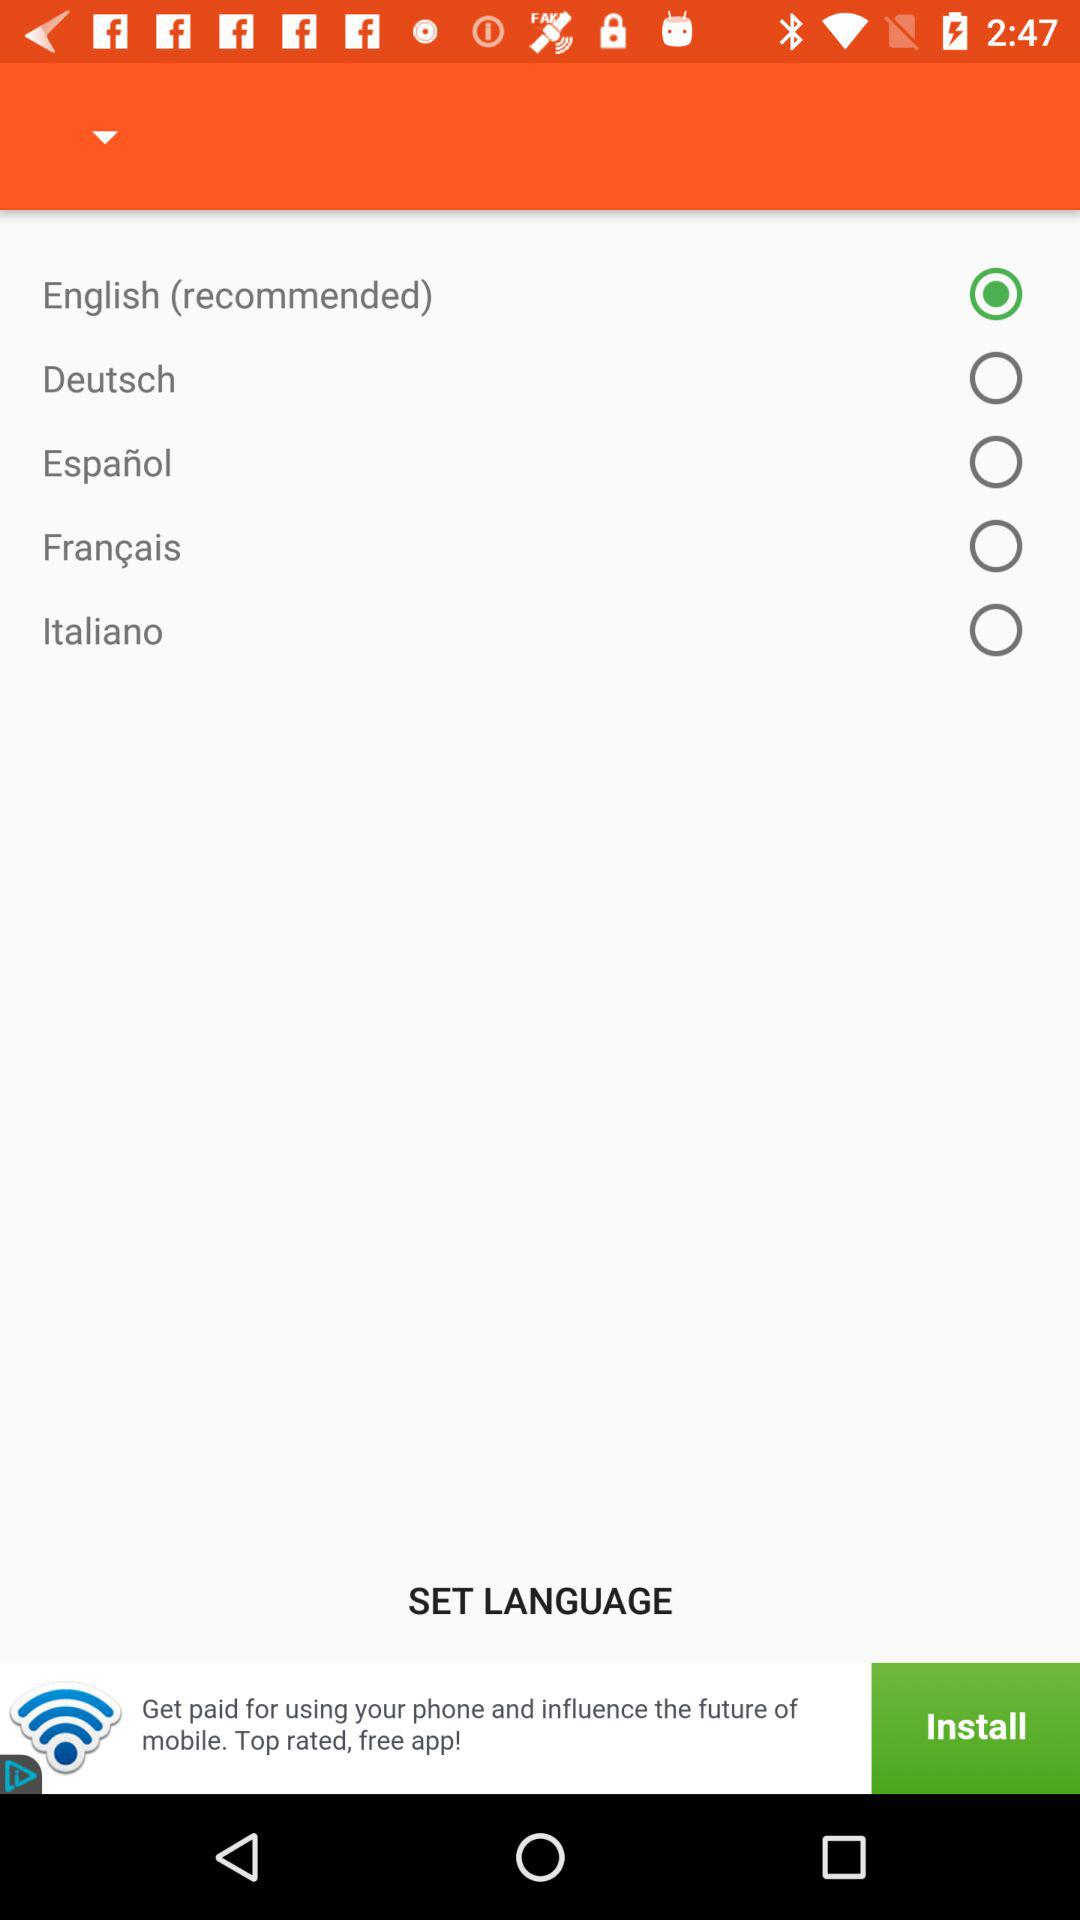How many languages are available to choose from?
Answer the question using a single word or phrase. 5 